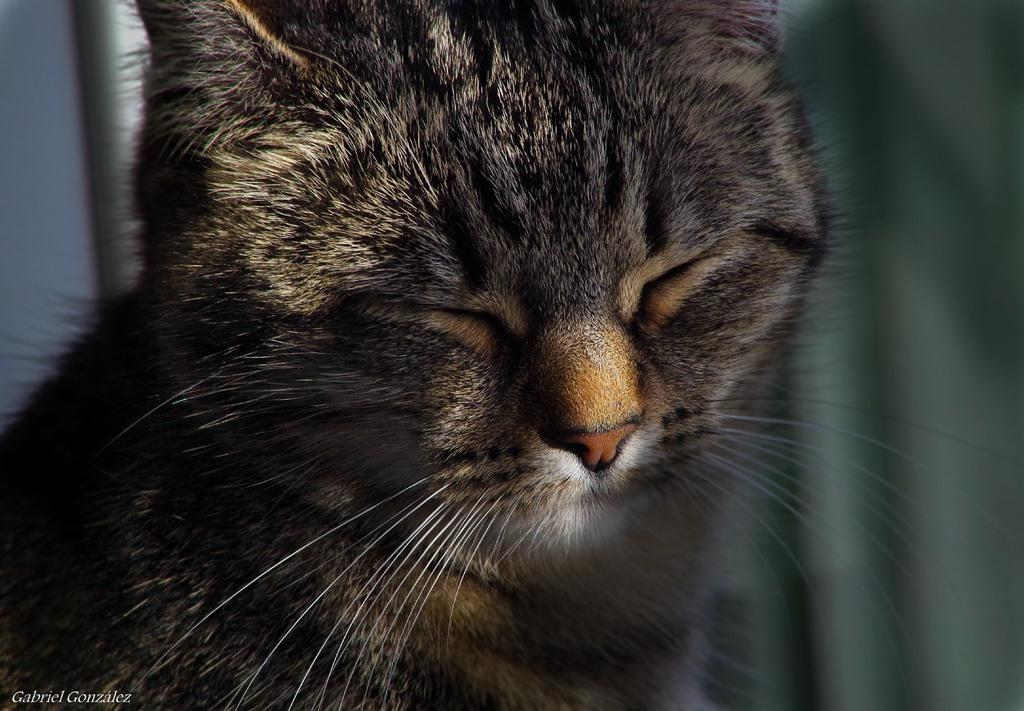What type of animal is in the image? There is a cat in the image. What is the cat's current state in the image? The cat has closed eyes. What type of kite is the cat holding in the image? There is no kite present in the image; it only features a cat with closed eyes. How many chickens are visible in the image? There are no chickens present in the image; it only features a cat with closed eyes. 